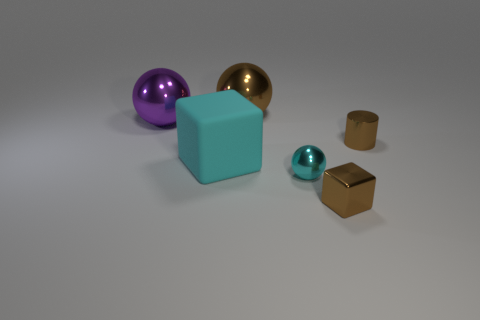Subtract all cylinders. How many objects are left? 5 Subtract all purple balls. How many balls are left? 2 Add 1 small metal blocks. How many small metal blocks are left? 2 Add 2 brown rubber blocks. How many brown rubber blocks exist? 2 Add 3 shiny cubes. How many objects exist? 9 Subtract all cyan balls. How many balls are left? 2 Subtract 0 blue spheres. How many objects are left? 6 Subtract 1 spheres. How many spheres are left? 2 Subtract all brown cubes. Subtract all gray balls. How many cubes are left? 1 Subtract all purple cylinders. How many cyan blocks are left? 1 